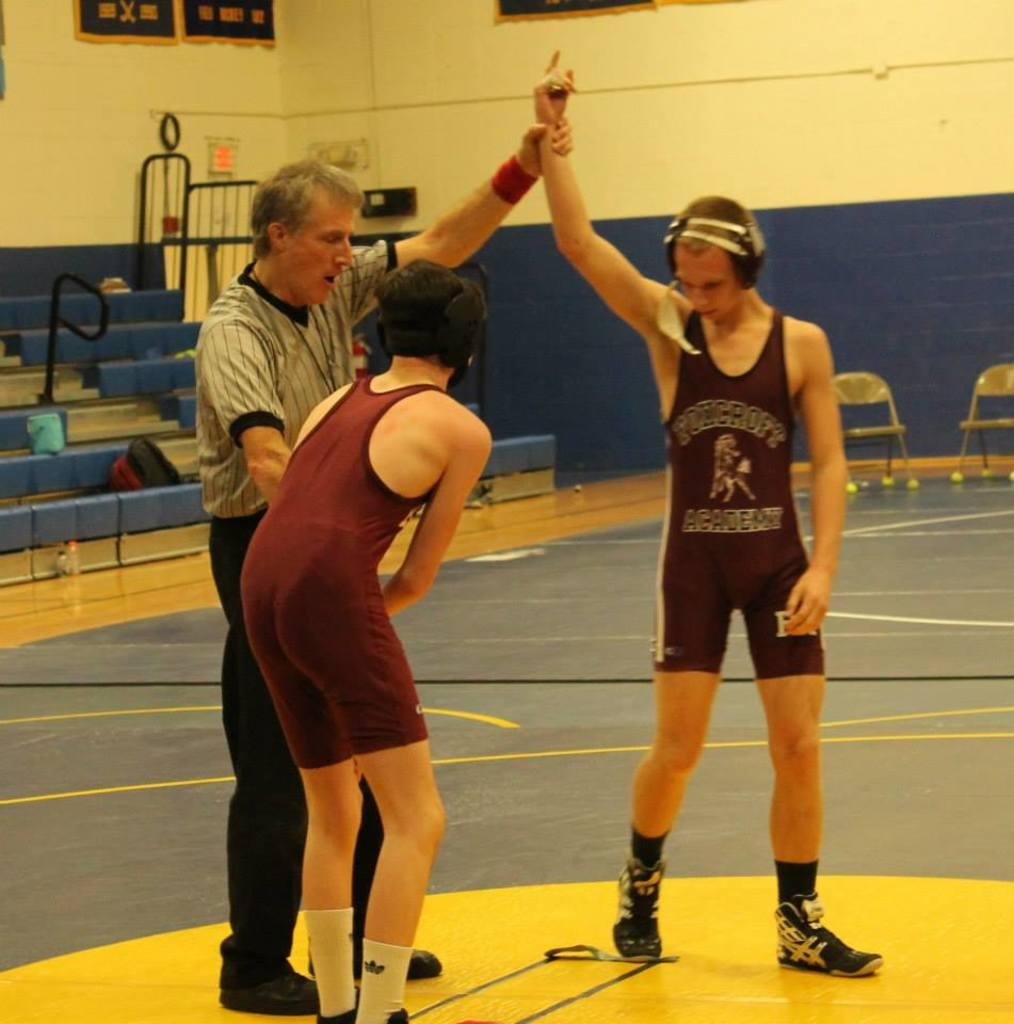Provide a one-sentence caption for the provided image. The two boys wear the same clothing from an academy. 